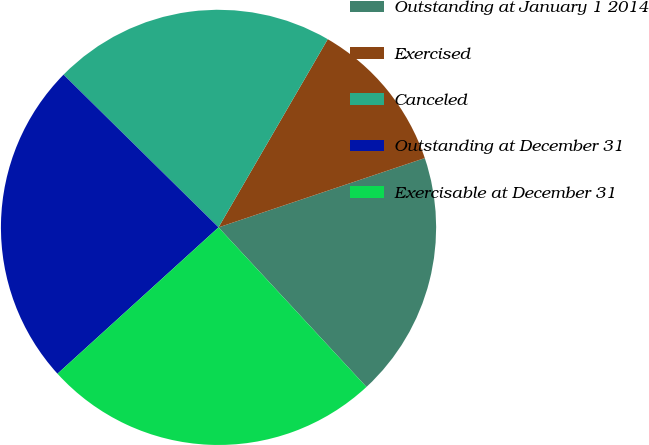Convert chart. <chart><loc_0><loc_0><loc_500><loc_500><pie_chart><fcel>Outstanding at January 1 2014<fcel>Exercised<fcel>Canceled<fcel>Outstanding at December 31<fcel>Exercisable at December 31<nl><fcel>18.26%<fcel>11.47%<fcel>20.99%<fcel>24.12%<fcel>25.16%<nl></chart> 